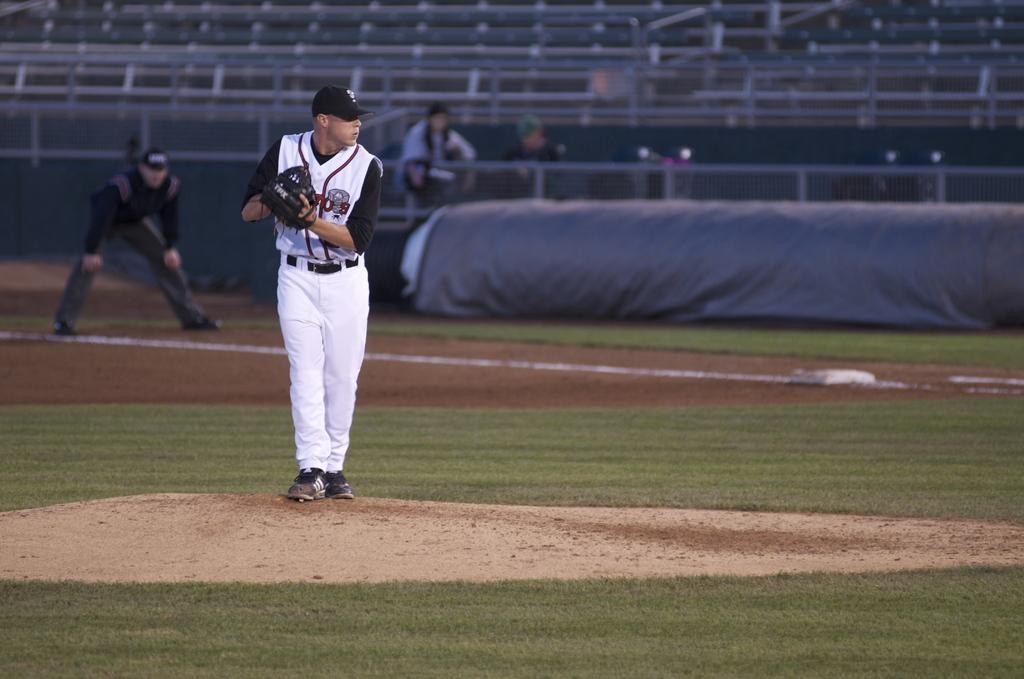In one or two sentences, can you explain what this image depicts? In the picture I can see a man on the left side. He is wearing a sports jersey and I can see the gloves in his hands. There is another man on the left side. It is looking like a ground covering cloth. In the background, I can see the metal fence and two persons. 